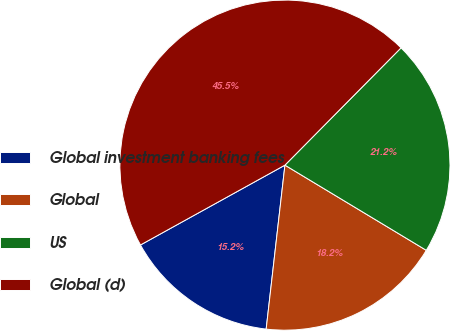Convert chart to OTSL. <chart><loc_0><loc_0><loc_500><loc_500><pie_chart><fcel>Global investment banking fees<fcel>Global<fcel>US<fcel>Global (d)<nl><fcel>15.15%<fcel>18.18%<fcel>21.21%<fcel>45.45%<nl></chart> 